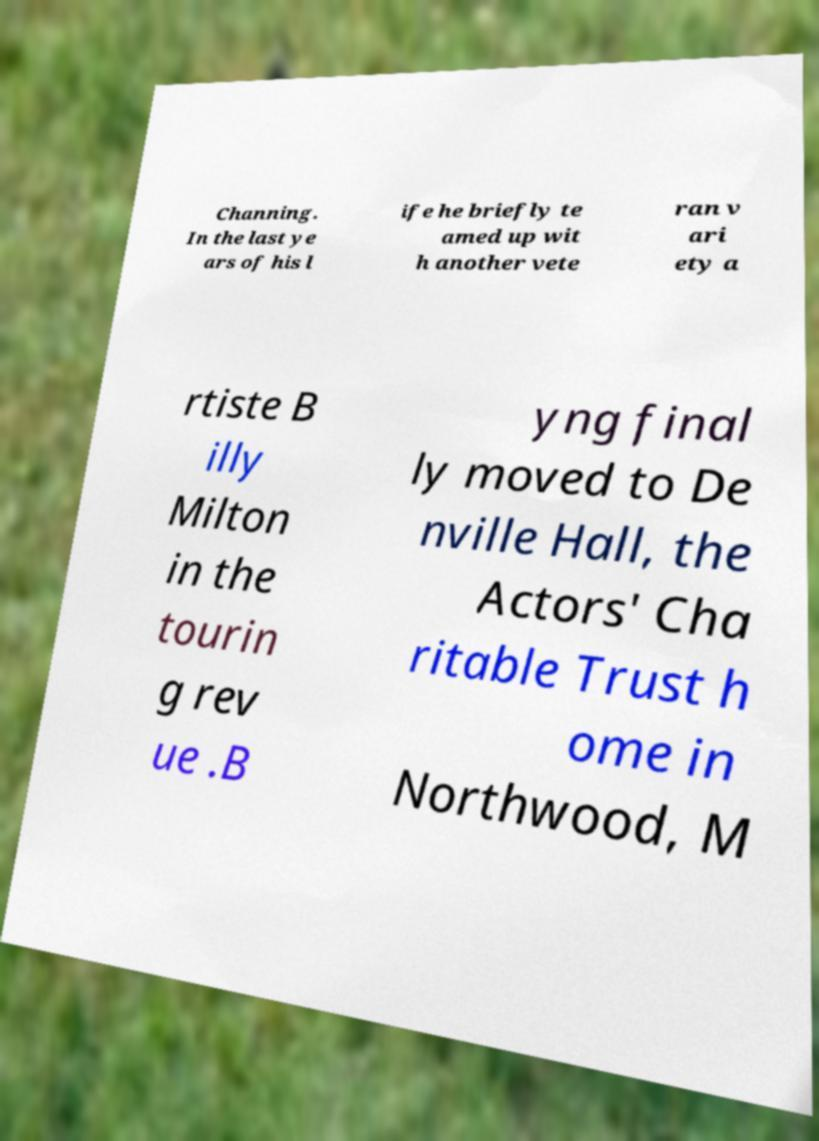Please read and relay the text visible in this image. What does it say? Channing. In the last ye ars of his l ife he briefly te amed up wit h another vete ran v ari ety a rtiste B illy Milton in the tourin g rev ue .B yng final ly moved to De nville Hall, the Actors' Cha ritable Trust h ome in Northwood, M 